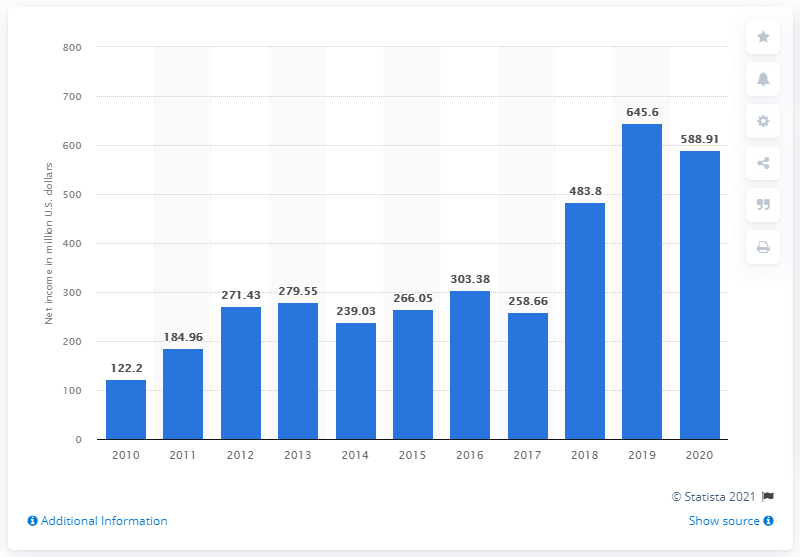List a handful of essential elements in this visual. In 2020, lululemon's global net income was 588.91 million dollars. 